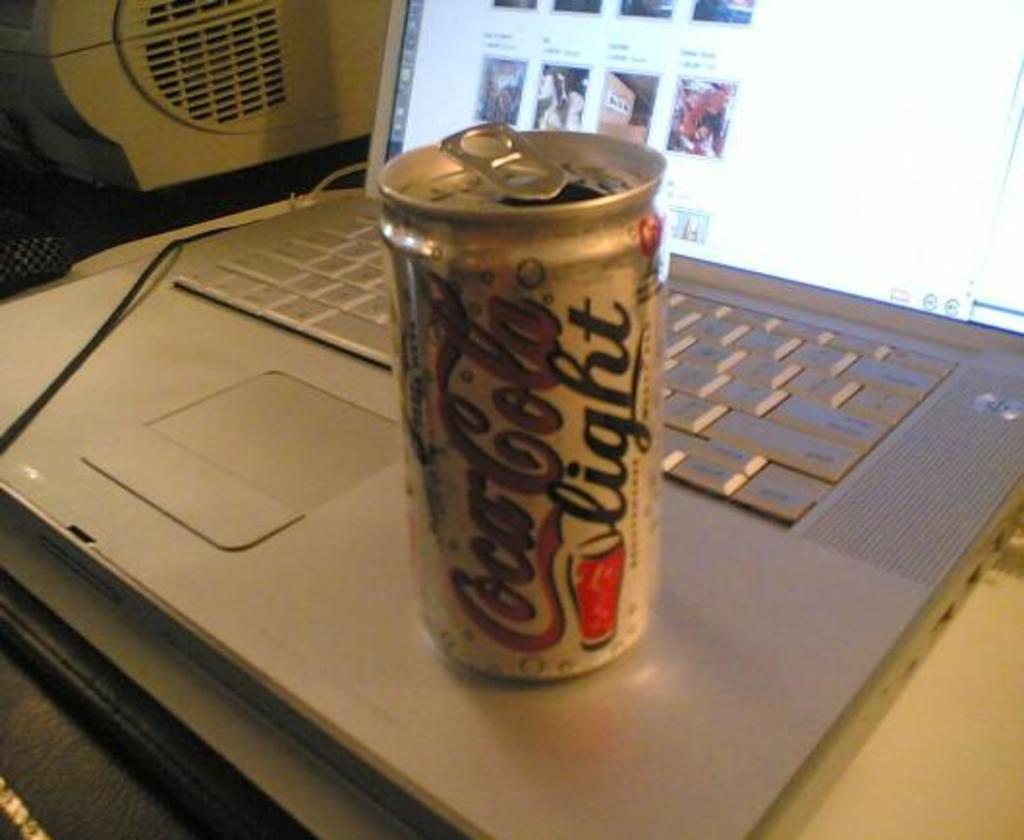Provide a one-sentence caption for the provided image. a Coors Light beer that is on a laptop. 